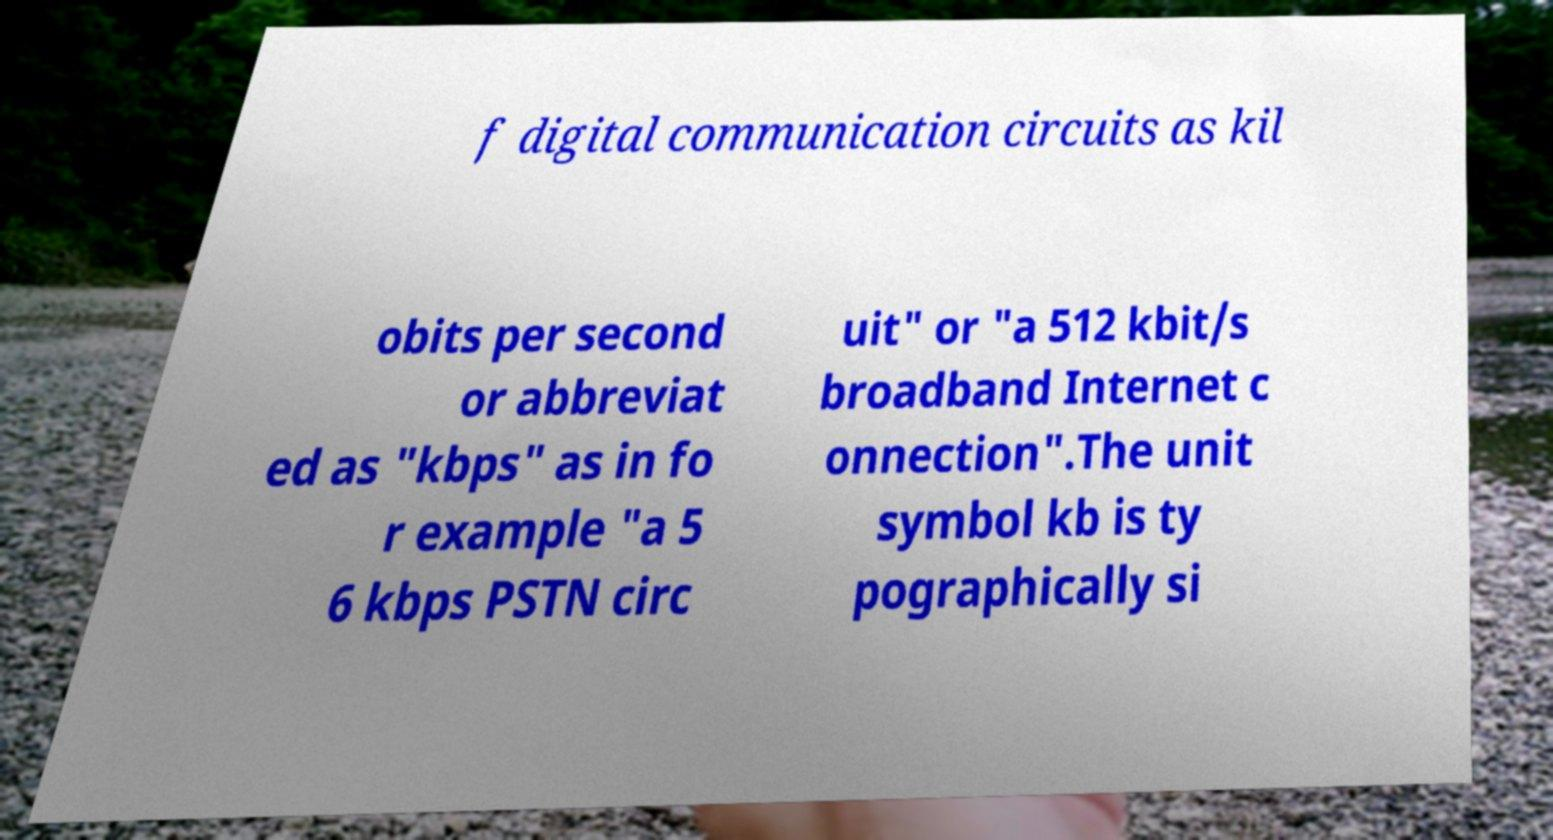What messages or text are displayed in this image? I need them in a readable, typed format. f digital communication circuits as kil obits per second or abbreviat ed as "kbps" as in fo r example "a 5 6 kbps PSTN circ uit" or "a 512 kbit/s broadband Internet c onnection".The unit symbol kb is ty pographically si 